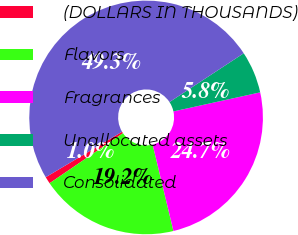Convert chart to OTSL. <chart><loc_0><loc_0><loc_500><loc_500><pie_chart><fcel>(DOLLARS IN THOUSANDS)<fcel>Flavors<fcel>Fragrances<fcel>Unallocated assets<fcel>Consolidated<nl><fcel>0.98%<fcel>19.23%<fcel>24.68%<fcel>5.81%<fcel>49.29%<nl></chart> 